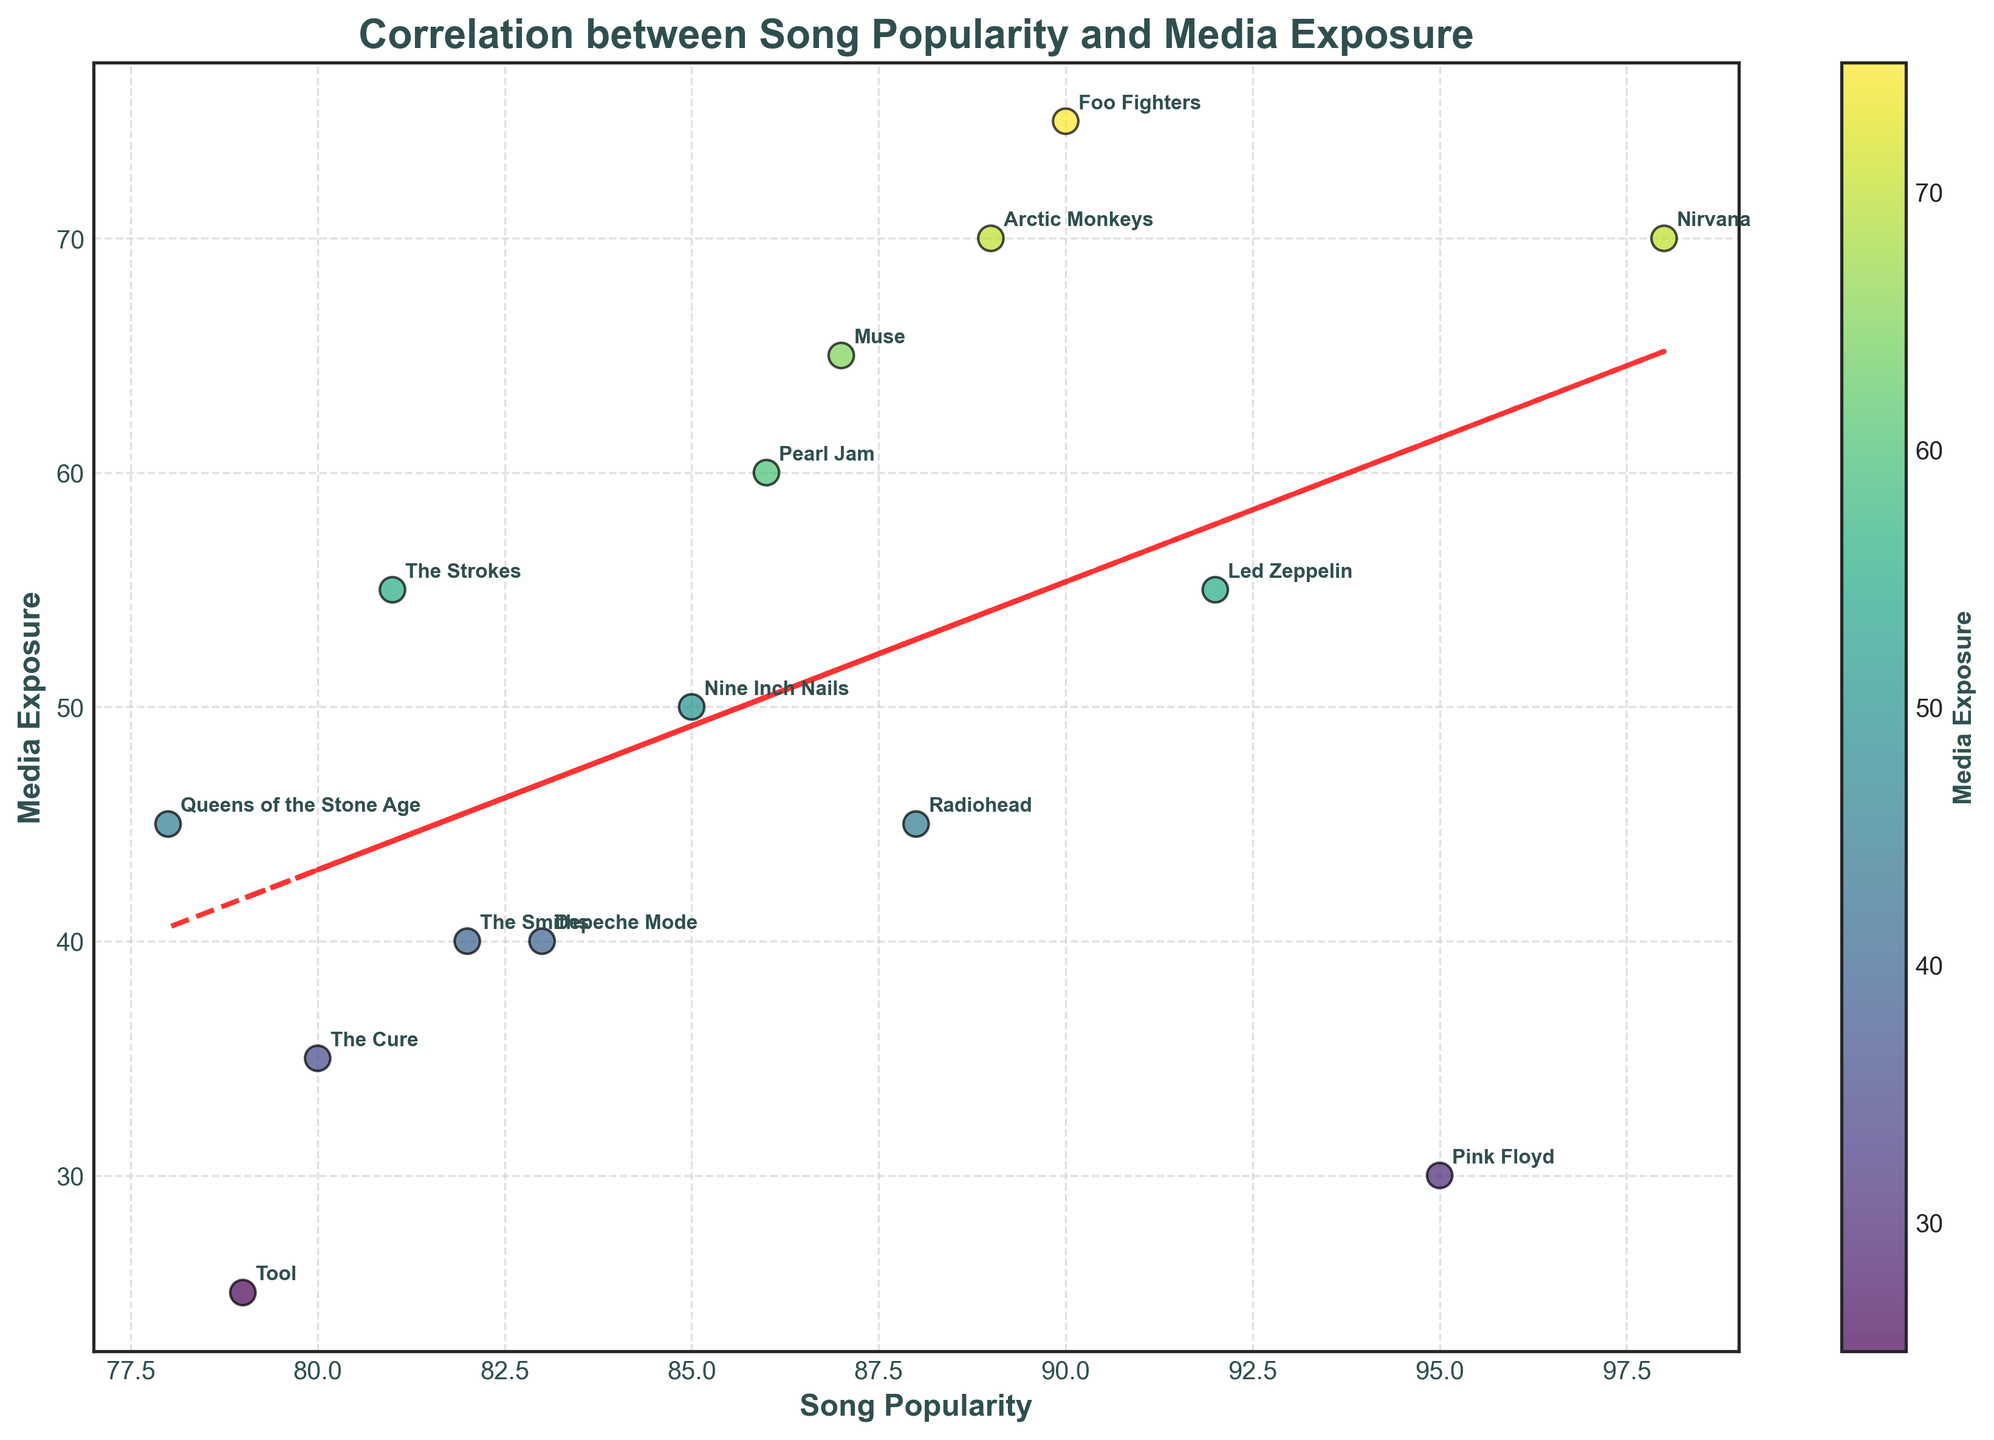What's the title of the plot? The title is usually prominently displayed at the top of the plot. In this case, it reads 'Correlation between Song Popularity and Media Exposure'.
Answer: Correlation between Song Popularity and Media Exposure Which band has the highest song popularity? The data points are labeled with band names, and the point that lies furthest to the right on the x-axis represents the highest song popularity. Here, Nirvana is the furthest right.
Answer: Nirvana How many bands have media exposure of 40? Look for data points along the y-axis at 40, check the labels of those points. The bands are The Smiths and Depeche Mode.
Answer: 2 What is the range of song popularity values? The range is found by identifying the minimum and maximum values on the x-axis. The minimum is 78 (Queens of the Stone Age), and the maximum is 98 (Nirvana). Calculate the difference: 98 - 78.
Answer: 20 Which band has the highest media exposure and what is its value? Locate the point at the highest position on the y-axis. The highest media exposure is 75 by Foo Fighters.
Answer: Foo Fighters, 75 How many data points are there in total? Count all the labeled points on the plot. In this plot, each labeled point represents a band, and there are 15 bands listed in the dataset.
Answer: 15 Is there a visible correlation between song popularity and media exposure? A trend line (like the red dashed one in the plot) helps visualize the overall correlation. If the line suggests that as song popularity increases, media exposure also increases, there is a positive correlation.
Answer: Yes, positive correlation Which band has a song popularity of 92 and what is its media exposure? Locate the point on the x-axis at 92 and check its corresponding y-value and label. This point is for Led Zeppelin with media exposure of 55.
Answer: Led Zeppelin, 55 Which bands have a song popularity greater than 90? Identify and list data points where the x-values (song popularity) are greater than 90. The bands are Pink Floyd, Nirvana, and Foo Fighters.
Answer: Pink Floyd, Nirvana, Foo Fighters What is the difference in media exposure between Radiohead and Tool? Check the y-values for Radiohead and Tool. Radiohead has 45, and Tool has 25. The difference is calculated by subtracting the smaller value from the larger value: 45 - 25.
Answer: 20 